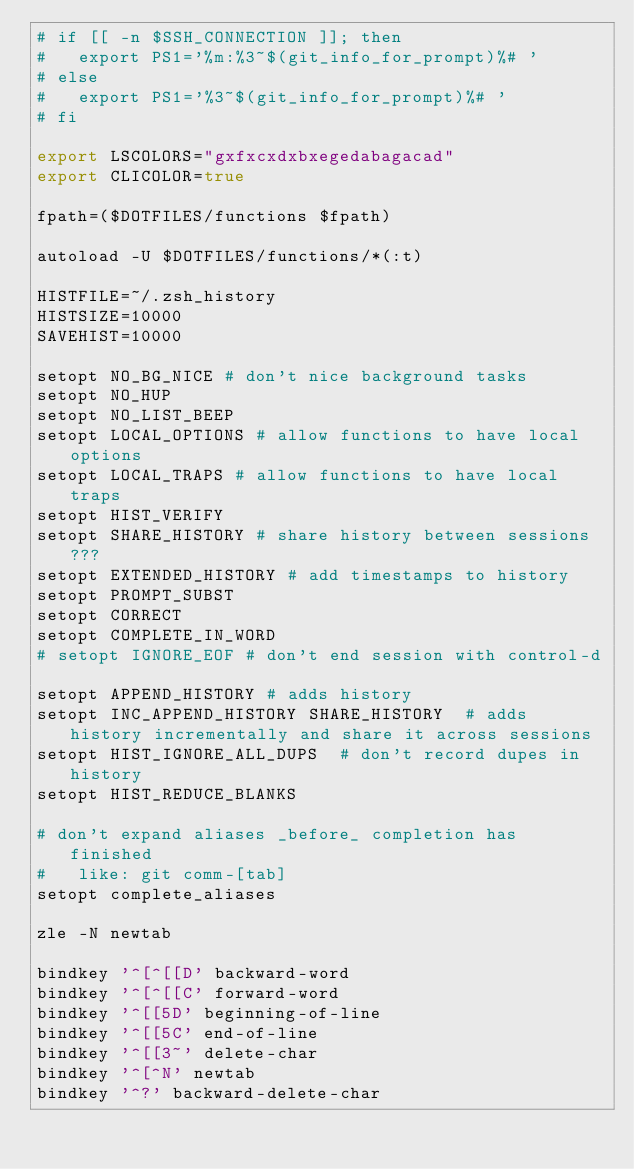<code> <loc_0><loc_0><loc_500><loc_500><_Bash_># if [[ -n $SSH_CONNECTION ]]; then
#   export PS1='%m:%3~$(git_info_for_prompt)%# '
# else
#   export PS1='%3~$(git_info_for_prompt)%# '
# fi

export LSCOLORS="gxfxcxdxbxegedabagacad"
export CLICOLOR=true

fpath=($DOTFILES/functions $fpath)

autoload -U $DOTFILES/functions/*(:t)

HISTFILE=~/.zsh_history
HISTSIZE=10000
SAVEHIST=10000

setopt NO_BG_NICE # don't nice background tasks
setopt NO_HUP
setopt NO_LIST_BEEP
setopt LOCAL_OPTIONS # allow functions to have local options
setopt LOCAL_TRAPS # allow functions to have local traps
setopt HIST_VERIFY
setopt SHARE_HISTORY # share history between sessions ???
setopt EXTENDED_HISTORY # add timestamps to history
setopt PROMPT_SUBST
setopt CORRECT
setopt COMPLETE_IN_WORD
# setopt IGNORE_EOF # don't end session with control-d

setopt APPEND_HISTORY # adds history
setopt INC_APPEND_HISTORY SHARE_HISTORY  # adds history incrementally and share it across sessions
setopt HIST_IGNORE_ALL_DUPS  # don't record dupes in history
setopt HIST_REDUCE_BLANKS

# don't expand aliases _before_ completion has finished
#   like: git comm-[tab]
setopt complete_aliases

zle -N newtab

bindkey '^[^[[D' backward-word
bindkey '^[^[[C' forward-word
bindkey '^[[5D' beginning-of-line
bindkey '^[[5C' end-of-line
bindkey '^[[3~' delete-char
bindkey '^[^N' newtab
bindkey '^?' backward-delete-char
</code> 